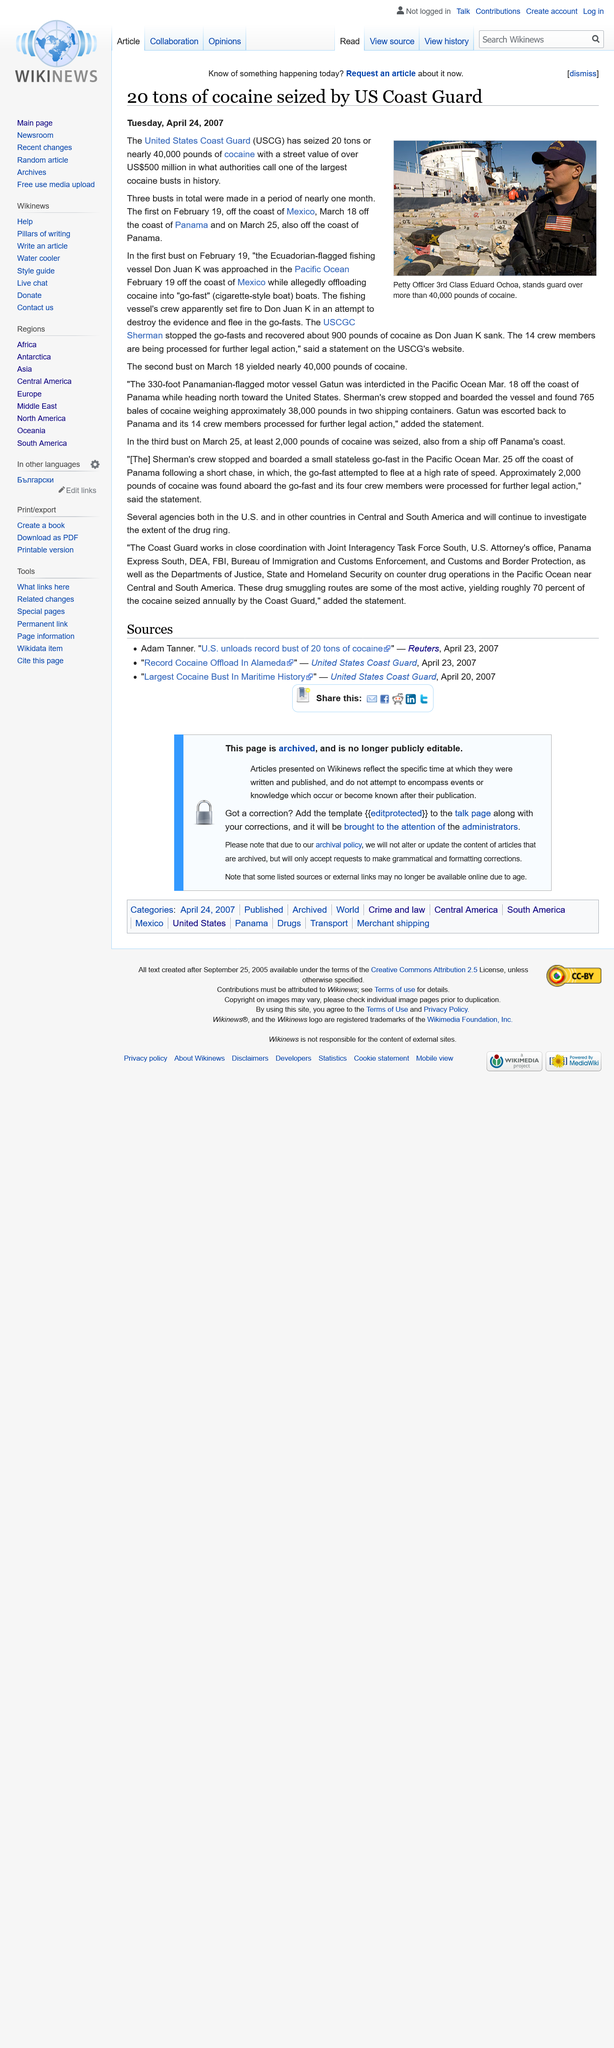Point out several critical features in this image. The fishing vessel Don Juan K displayed the flag of Ecuador. In total, 20 tons of cocaine, weighing almost 40,000 pounds, were seized. Fourteen crew members were being processed for further legal action. 